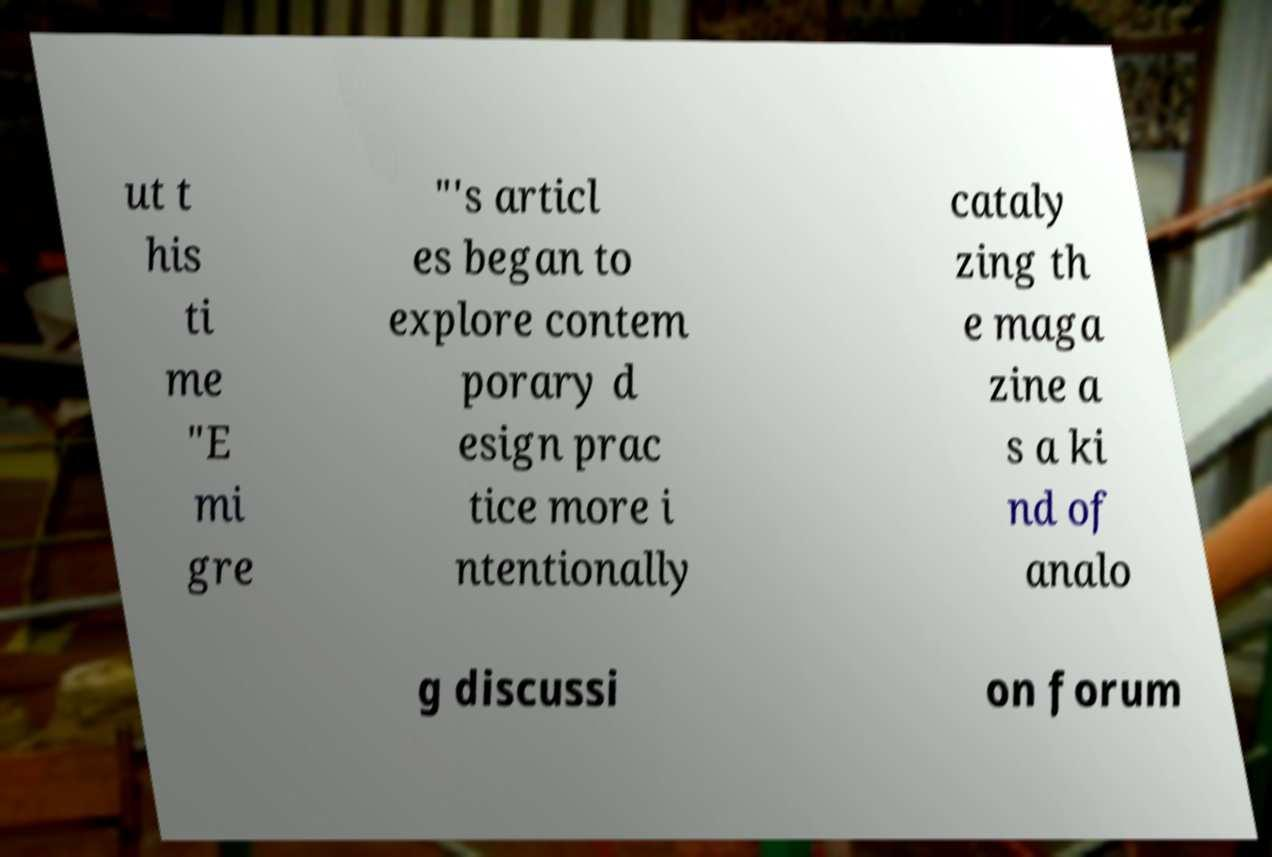Can you accurately transcribe the text from the provided image for me? ut t his ti me "E mi gre "'s articl es began to explore contem porary d esign prac tice more i ntentionally cataly zing th e maga zine a s a ki nd of analo g discussi on forum 